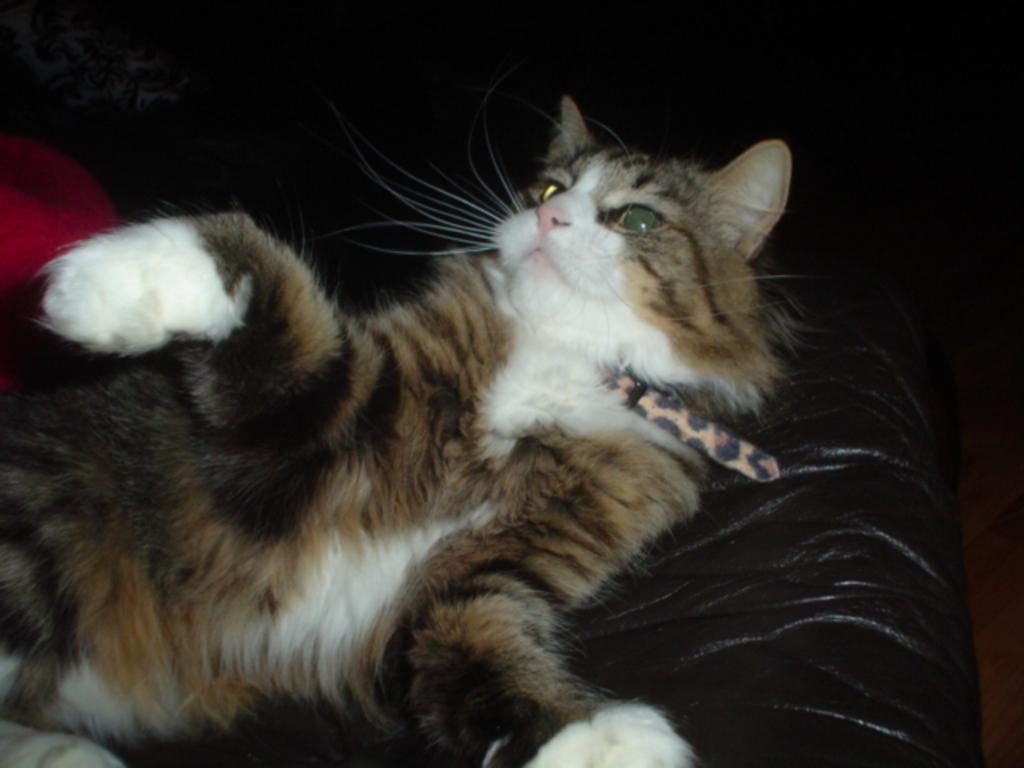What type of animal is present in the image? There is a cat in the image. What is the cat doing in the image? The cat is lying on a chair. How many cattle are present in the image? There are no cattle present in the image; it features a cat lying on a chair. What type of attention is the cat receiving in the image? The image does not indicate whether the cat is receiving any attention. 